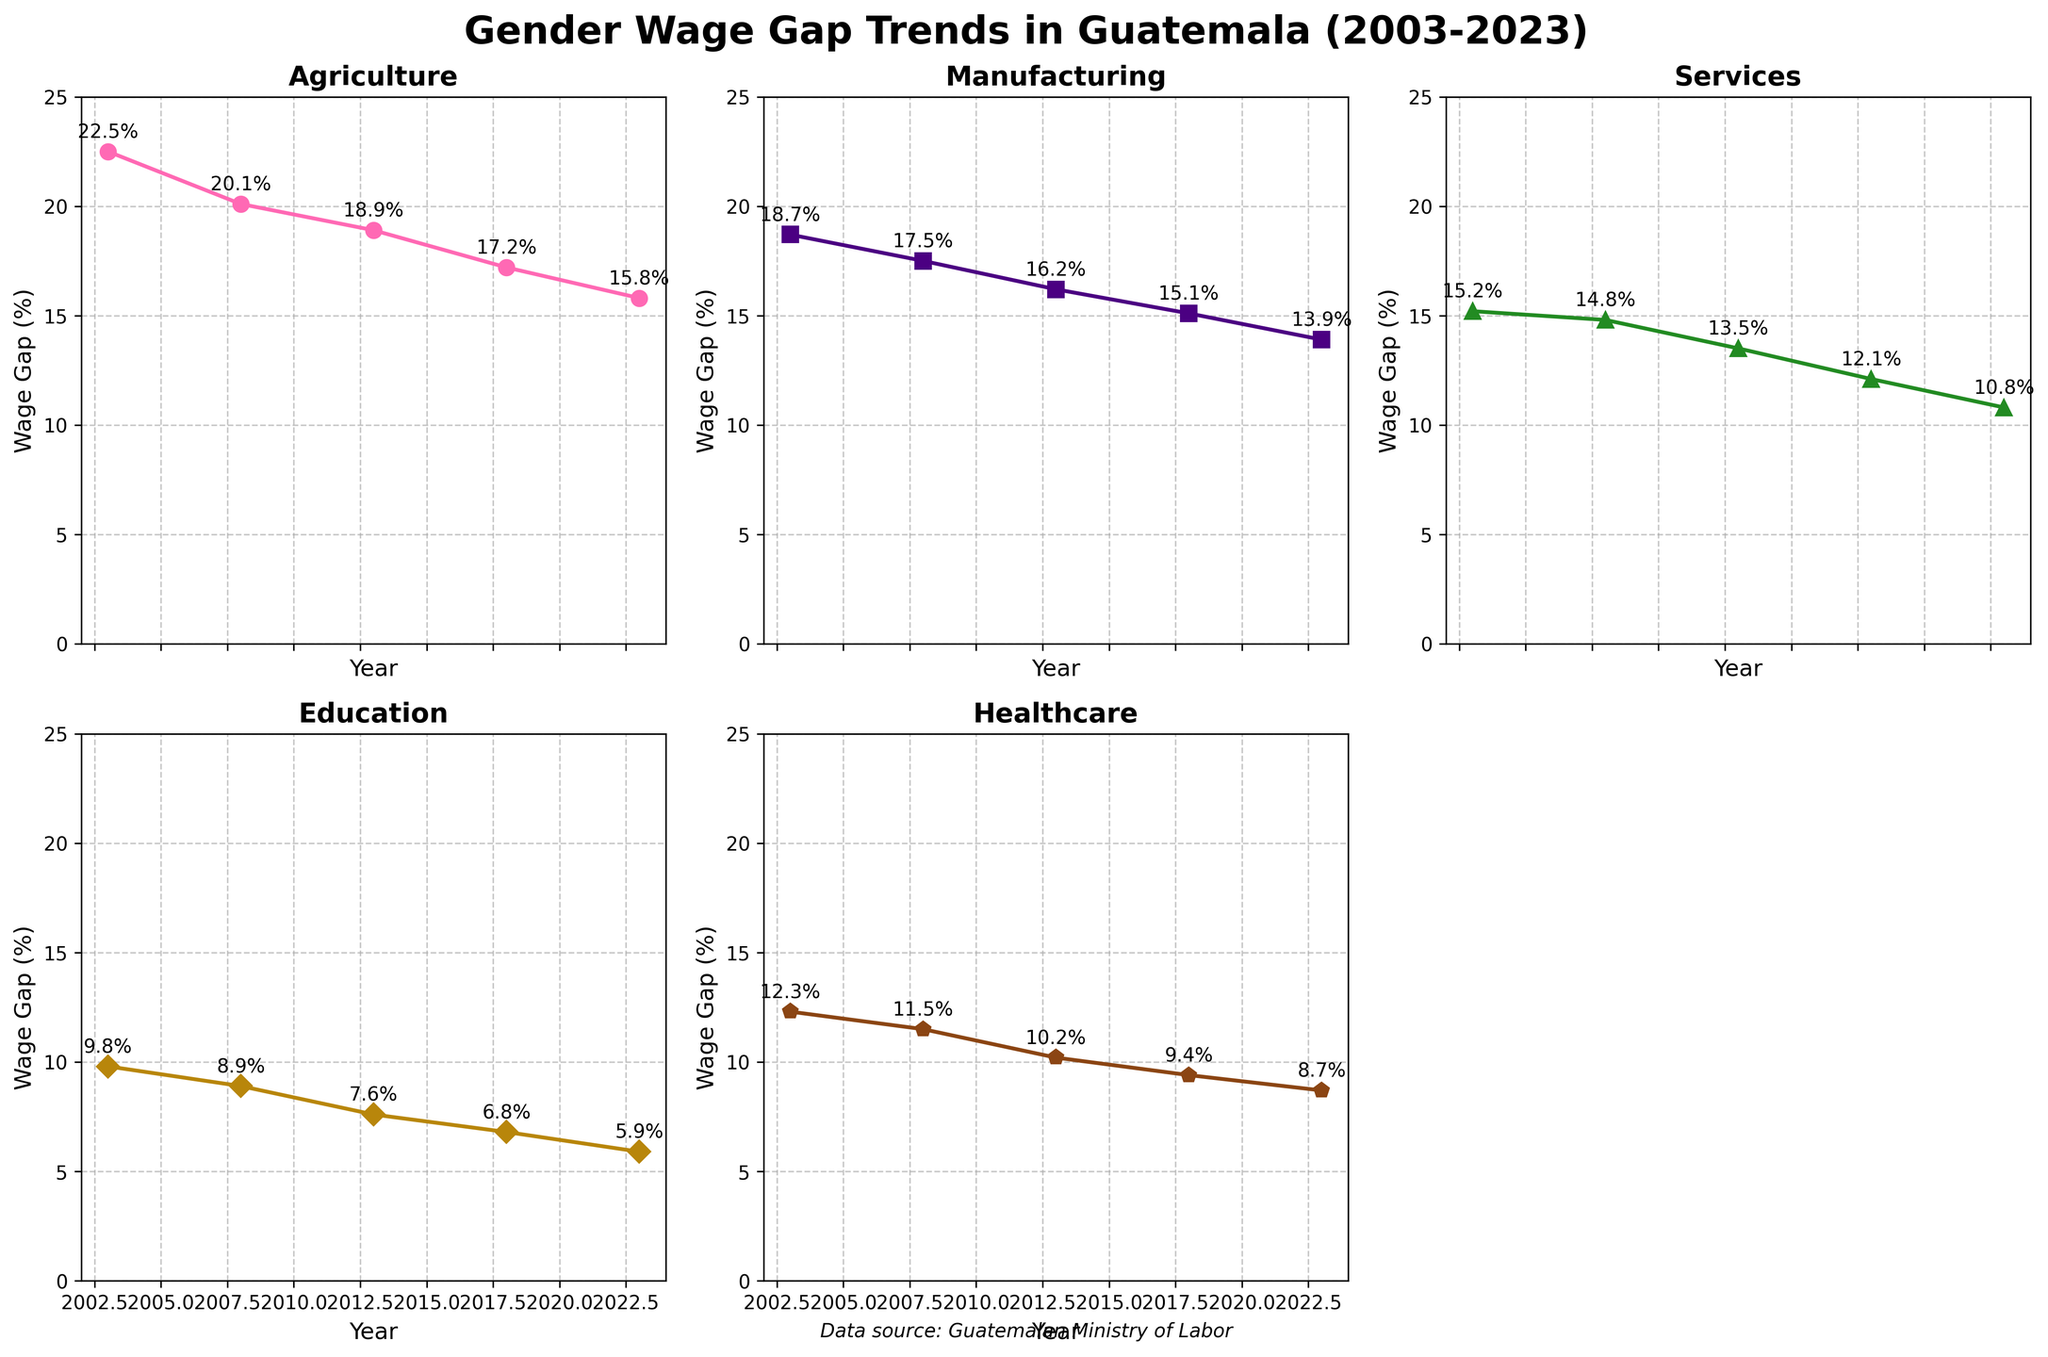What is the title of the figure? The title is at the top of the figure and it's written in large, bold font. It reads "Gender Wage Gap Trends in Guatemala (2003-2023)"
Answer: Gender Wage Gap Trends in Guatemala (2003-2023) What is the data source mentioned in the figure? The data source is indicated at the bottom of the figure, in italic font. It says "Data source: Guatemalan Ministry of Labor"
Answer: Guatemalan Ministry of Labor In which year did the wage gap in the Agriculture sector decrease below 20% for the first time? By looking at the line chart for the Agriculture sector, we see that in 2008 the wage gap decreased to 20.1% and continued decreasing in subsequent years. Therefore, the first year it went below 20% was in 2013
Answer: 2013 What sector had the smallest gender wage gap percentage in 2023? By checking the values for all sectors in 2023, we see that the Education sector has the smallest gender wage gap percentage, which is 5.9%
Answer: Education Which sector showed the largest decrease in the wage gap between 2003 and 2023? Calculate the difference for each sector by subtracting the 2023 value from the 2003 value. Agriculture: 22.5 - 15.8 = 6.7, Manufacturing: 18.7 - 13.9 = 4.8, Services: 15.2 - 10.8 = 4.4, Education: 9.8 - 5.9 = 3.9, Healthcare: 12.3 - 8.7 = 3.6. The Agriculture sector shows the largest decrease
Answer: Agriculture Between 2008 and 2018, which sector saw the smallest reduction in the wage gap? Calculate the difference between 2018 and 2008 for each sector. Agriculture: 20.1 - 17.2 = 2.9, Manufacturing: 17.5 - 15.1 = 2.4, Services: 14.8 - 12.1 = 2.7, Education: 8.9 - 6.8 = 2.1, Healthcare: 11.5 - 9.4 = 2.1. The Education and Healthcare sectors saw the smallest reduction
Answer: Education and Healthcare What is the percentage difference in the gender wage gap between the Education and Healthcare sectors in 2013? Subtract the value for Education from the value for Healthcare in 2013. Healthcare: 10.2%, Education: 7.6%. So the difference is 10.2 - 7.6 = 2.6%
Answer: 2.6% Which year had the smallest overall gender wage gap percentage across all sectors? Observe the values for all sectors over the years and identify the year with the smallest numbers across sectors. For each year, we have: 2003: 22.5, 18.7, 15.2, 9.8, 12.3; 2008: 20.1, 17.5, 14.8, 8.9, 11.5; 2013: 18.9, 16.2, 13.5, 7.6, 10.2; 2018: 17.2, 15.1, 12.1, 6.8, 9.4; 2023: 15.8, 13.9, 10.8, 5.9, 8.7. The year 2023 has the smallest numbers
Answer: 2023 